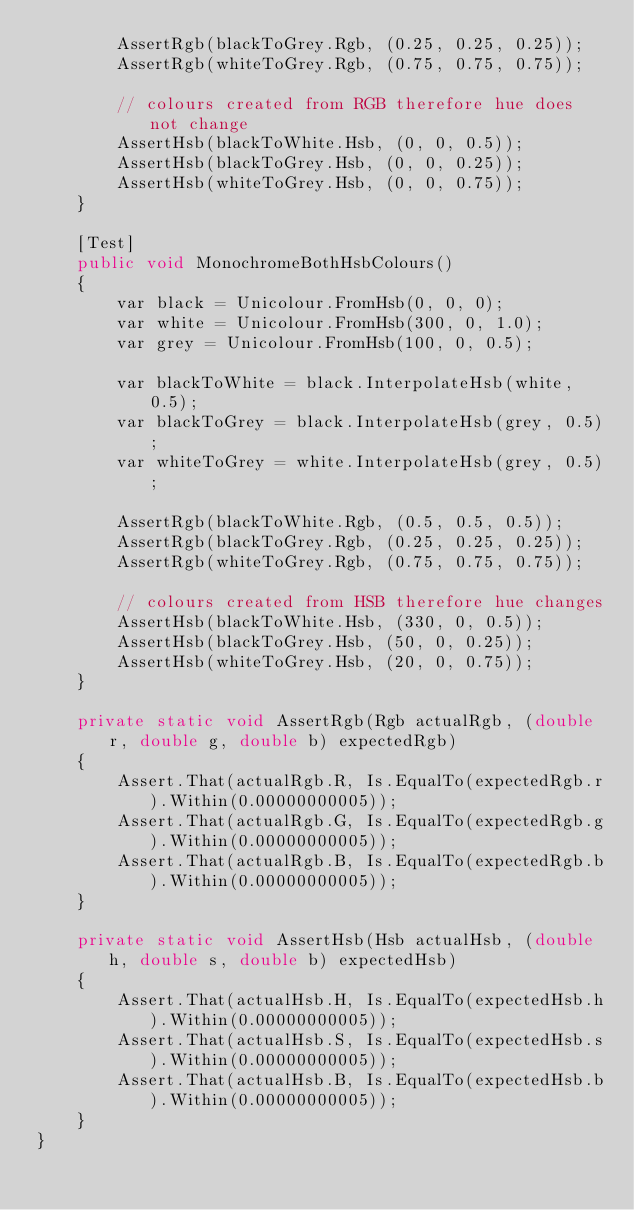<code> <loc_0><loc_0><loc_500><loc_500><_C#_>        AssertRgb(blackToGrey.Rgb, (0.25, 0.25, 0.25));
        AssertRgb(whiteToGrey.Rgb, (0.75, 0.75, 0.75));
        
        // colours created from RGB therefore hue does not change
        AssertHsb(blackToWhite.Hsb, (0, 0, 0.5));
        AssertHsb(blackToGrey.Hsb, (0, 0, 0.25));
        AssertHsb(whiteToGrey.Hsb, (0, 0, 0.75));
    }
    
    [Test]
    public void MonochromeBothHsbColours()
    {
        var black = Unicolour.FromHsb(0, 0, 0);
        var white = Unicolour.FromHsb(300, 0, 1.0);
        var grey = Unicolour.FromHsb(100, 0, 0.5);

        var blackToWhite = black.InterpolateHsb(white, 0.5);
        var blackToGrey = black.InterpolateHsb(grey, 0.5);
        var whiteToGrey = white.InterpolateHsb(grey, 0.5);
        
        AssertRgb(blackToWhite.Rgb, (0.5, 0.5, 0.5));
        AssertRgb(blackToGrey.Rgb, (0.25, 0.25, 0.25));
        AssertRgb(whiteToGrey.Rgb, (0.75, 0.75, 0.75));
        
        // colours created from HSB therefore hue changes
        AssertHsb(blackToWhite.Hsb, (330, 0, 0.5));
        AssertHsb(blackToGrey.Hsb, (50, 0, 0.25));
        AssertHsb(whiteToGrey.Hsb, (20, 0, 0.75));
    }
    
    private static void AssertRgb(Rgb actualRgb, (double r, double g, double b) expectedRgb)
    {
        Assert.That(actualRgb.R, Is.EqualTo(expectedRgb.r).Within(0.00000000005));
        Assert.That(actualRgb.G, Is.EqualTo(expectedRgb.g).Within(0.00000000005));
        Assert.That(actualRgb.B, Is.EqualTo(expectedRgb.b).Within(0.00000000005));
    }

    private static void AssertHsb(Hsb actualHsb, (double h, double s, double b) expectedHsb)
    {
        Assert.That(actualHsb.H, Is.EqualTo(expectedHsb.h).Within(0.00000000005));
        Assert.That(actualHsb.S, Is.EqualTo(expectedHsb.s).Within(0.00000000005));
        Assert.That(actualHsb.B, Is.EqualTo(expectedHsb.b).Within(0.00000000005));
    }
}</code> 